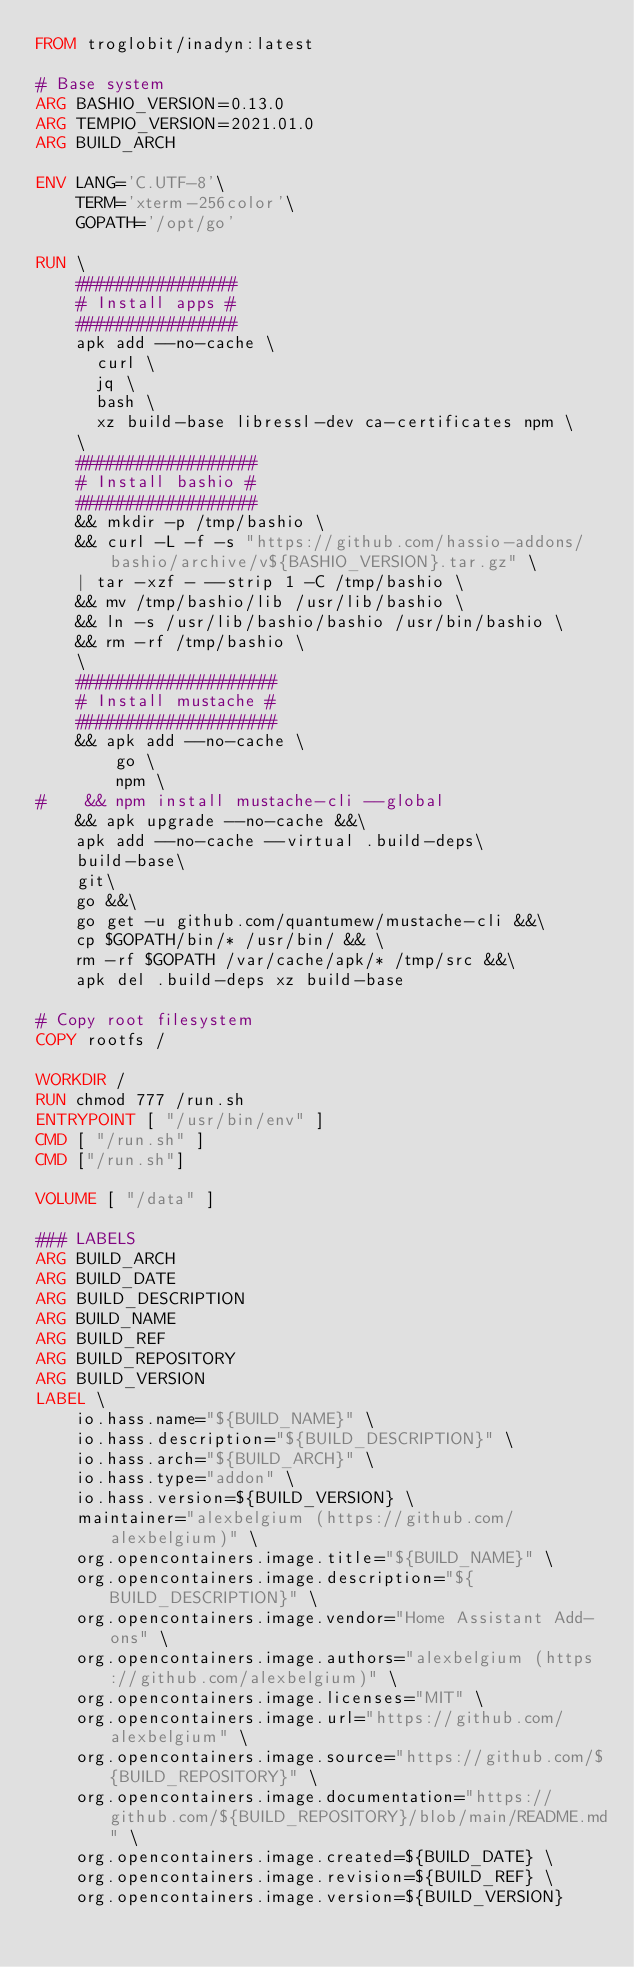<code> <loc_0><loc_0><loc_500><loc_500><_Dockerfile_>FROM troglobit/inadyn:latest

# Base system
ARG BASHIO_VERSION=0.13.0
ARG TEMPIO_VERSION=2021.01.0
ARG BUILD_ARCH

ENV LANG='C.UTF-8'\
    TERM='xterm-256color'\
    GOPATH='/opt/go'

RUN \
    ################
    # Install apps #
    ################
    apk add --no-cache \
      curl \
      jq \
      bash \
      xz build-base libressl-dev ca-certificates npm \
    \
    ##################
    # Install bashio #
    ##################
    && mkdir -p /tmp/bashio \
    && curl -L -f -s "https://github.com/hassio-addons/bashio/archive/v${BASHIO_VERSION}.tar.gz" \
    | tar -xzf - --strip 1 -C /tmp/bashio \
    && mv /tmp/bashio/lib /usr/lib/bashio \
    && ln -s /usr/lib/bashio/bashio /usr/bin/bashio \
    && rm -rf /tmp/bashio \
    \
    ####################
    # Install mustache #
    ####################
    && apk add --no-cache \
        go \
        npm \
#    && npm install mustache-cli --global        
    && apk upgrade --no-cache &&\
    apk add --no-cache --virtual .build-deps\
    build-base\
    git\
    go &&\
    go get -u github.com/quantumew/mustache-cli &&\
    cp $GOPATH/bin/* /usr/bin/ && \
    rm -rf $GOPATH /var/cache/apk/* /tmp/src &&\
    apk del .build-deps xz build-base

# Copy root filesystem
COPY rootfs / 

WORKDIR /
RUN chmod 777 /run.sh
ENTRYPOINT [ "/usr/bin/env" ]
CMD [ "/run.sh" ] 
CMD ["/run.sh"]

VOLUME [ "/data" ]

### LABELS
ARG BUILD_ARCH
ARG BUILD_DATE
ARG BUILD_DESCRIPTION
ARG BUILD_NAME
ARG BUILD_REF
ARG BUILD_REPOSITORY
ARG BUILD_VERSION
LABEL \
    io.hass.name="${BUILD_NAME}" \
    io.hass.description="${BUILD_DESCRIPTION}" \
    io.hass.arch="${BUILD_ARCH}" \
    io.hass.type="addon" \
    io.hass.version=${BUILD_VERSION} \
    maintainer="alexbelgium (https://github.com/alexbelgium)" \
    org.opencontainers.image.title="${BUILD_NAME}" \
    org.opencontainers.image.description="${BUILD_DESCRIPTION}" \
    org.opencontainers.image.vendor="Home Assistant Add-ons" \
    org.opencontainers.image.authors="alexbelgium (https://github.com/alexbelgium)" \
    org.opencontainers.image.licenses="MIT" \
    org.opencontainers.image.url="https://github.com/alexbelgium" \
    org.opencontainers.image.source="https://github.com/${BUILD_REPOSITORY}" \
    org.opencontainers.image.documentation="https://github.com/${BUILD_REPOSITORY}/blob/main/README.md" \
    org.opencontainers.image.created=${BUILD_DATE} \
    org.opencontainers.image.revision=${BUILD_REF} \
    org.opencontainers.image.version=${BUILD_VERSION}
</code> 